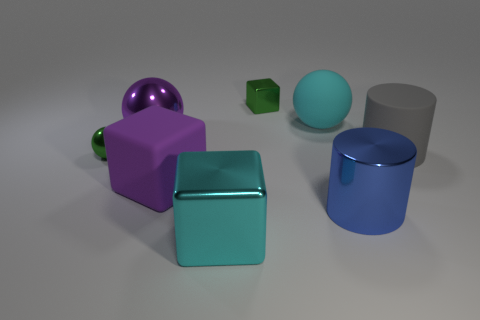Subtract all large purple balls. How many balls are left? 2 Subtract all cyan spheres. How many spheres are left? 2 Subtract all cubes. How many objects are left? 5 Add 2 green shiny objects. How many objects exist? 10 Subtract 0 yellow spheres. How many objects are left? 8 Subtract 1 balls. How many balls are left? 2 Subtract all purple balls. Subtract all green cylinders. How many balls are left? 2 Subtract all purple balls. How many red blocks are left? 0 Subtract all small green metallic things. Subtract all large spheres. How many objects are left? 4 Add 8 large cylinders. How many large cylinders are left? 10 